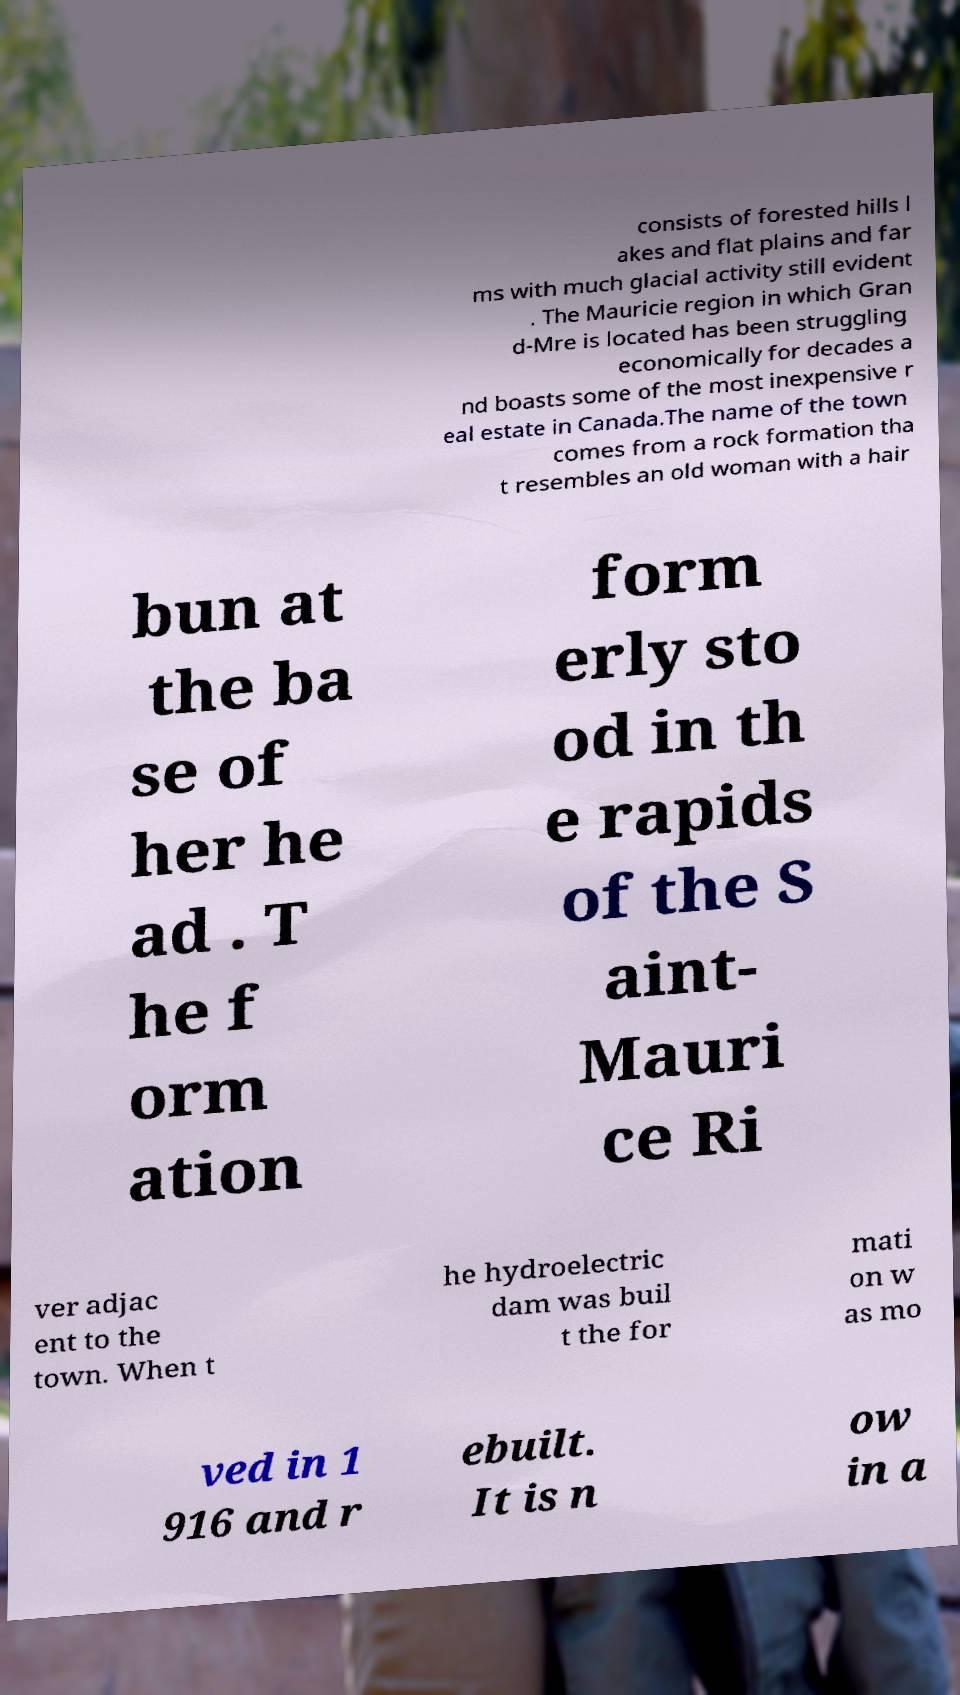There's text embedded in this image that I need extracted. Can you transcribe it verbatim? consists of forested hills l akes and flat plains and far ms with much glacial activity still evident . The Mauricie region in which Gran d-Mre is located has been struggling economically for decades a nd boasts some of the most inexpensive r eal estate in Canada.The name of the town comes from a rock formation tha t resembles an old woman with a hair bun at the ba se of her he ad . T he f orm ation form erly sto od in th e rapids of the S aint- Mauri ce Ri ver adjac ent to the town. When t he hydroelectric dam was buil t the for mati on w as mo ved in 1 916 and r ebuilt. It is n ow in a 